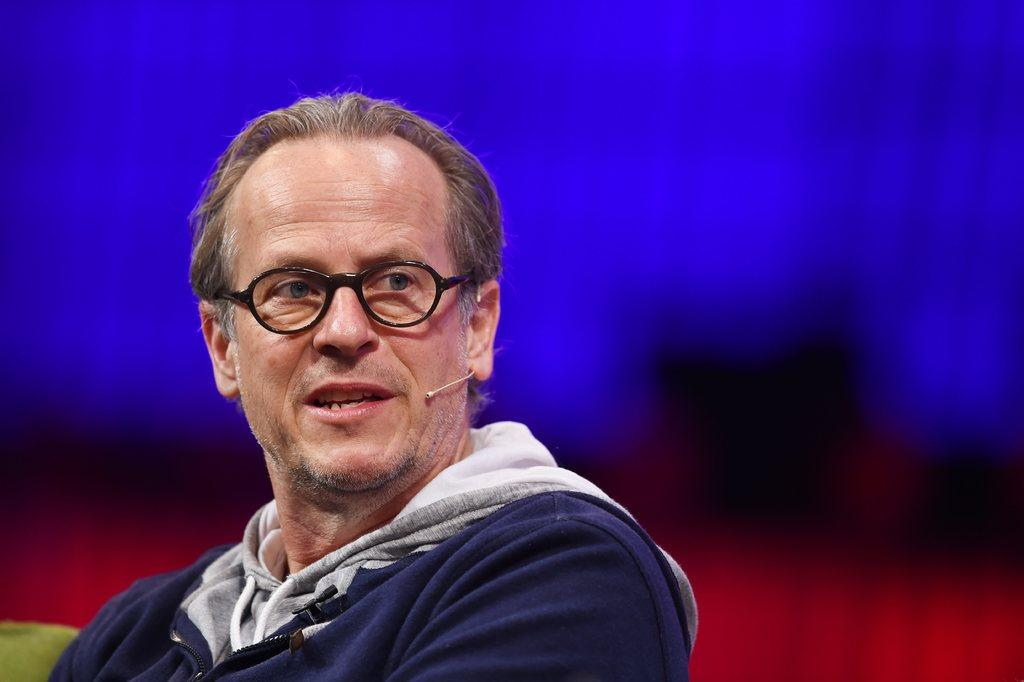What is the main subject of the image? There is a person in the image. What is the person wearing? The person is wearing a blue color hoodie. Can you describe any accessories the person is wearing? The person is wearing spectacles. What can be seen near the person's ear? There is a mic near the person's ear. What colors are present in the background of the image? The background of the image has blue, black, and red colors. Can you tell me how many baskets are visible in the image? There are no baskets present in the image. What type of thunder can be heard in the background of the image? There is no thunder present in the image; it is a still image with no sound. 